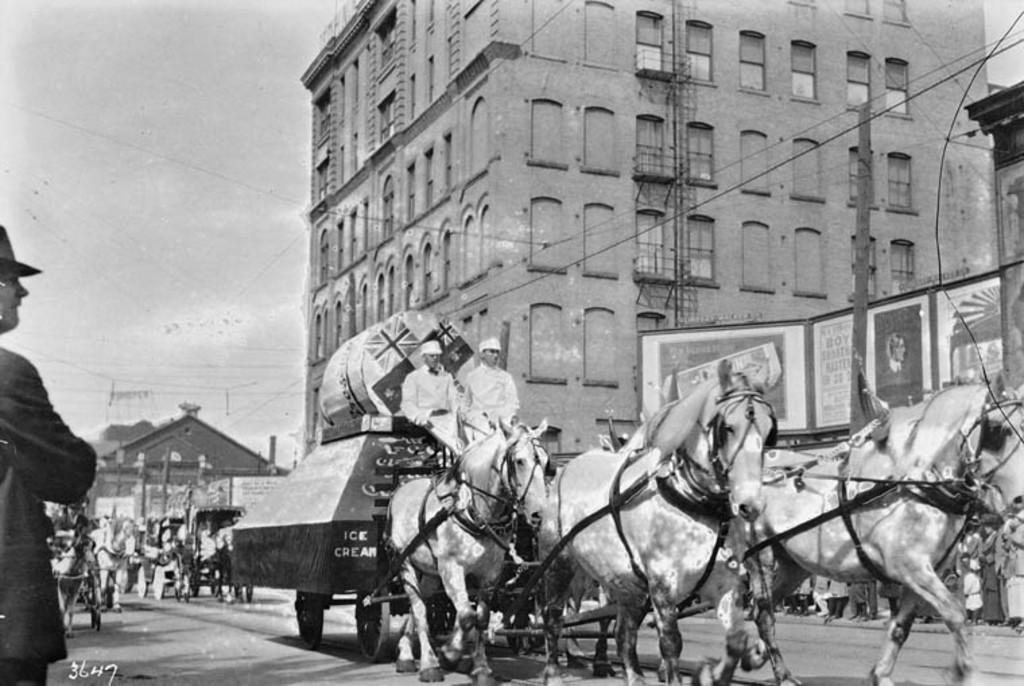In one or two sentences, can you explain what this image depicts? As we can see in the image there is a sky, buildings and few people over here and there are horses. 